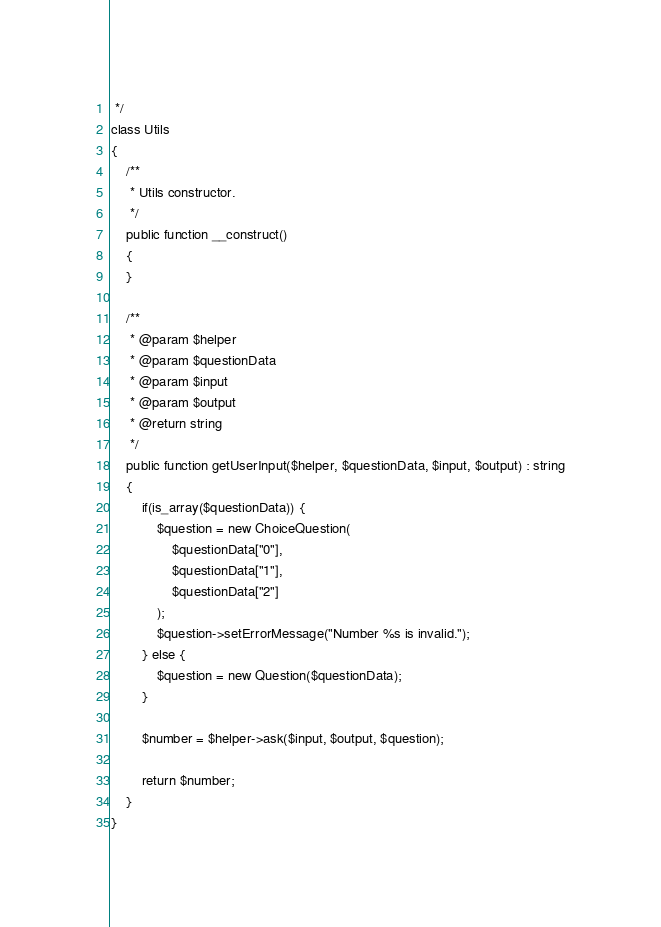<code> <loc_0><loc_0><loc_500><loc_500><_PHP_> */
class Utils
{
    /**
     * Utils constructor.
     */
    public function __construct()
    {
    }

    /**
     * @param $helper
     * @param $questionData
     * @param $input
     * @param $output
     * @return string
     */
    public function getUserInput($helper, $questionData, $input, $output) : string
    {
        if(is_array($questionData)) {
            $question = new ChoiceQuestion(
                $questionData["0"],
                $questionData["1"],
                $questionData["2"]
            );
            $question->setErrorMessage("Number %s is invalid.");
        } else {
            $question = new Question($questionData);
        }

        $number = $helper->ask($input, $output, $question);

        return $number;
    }
}</code> 